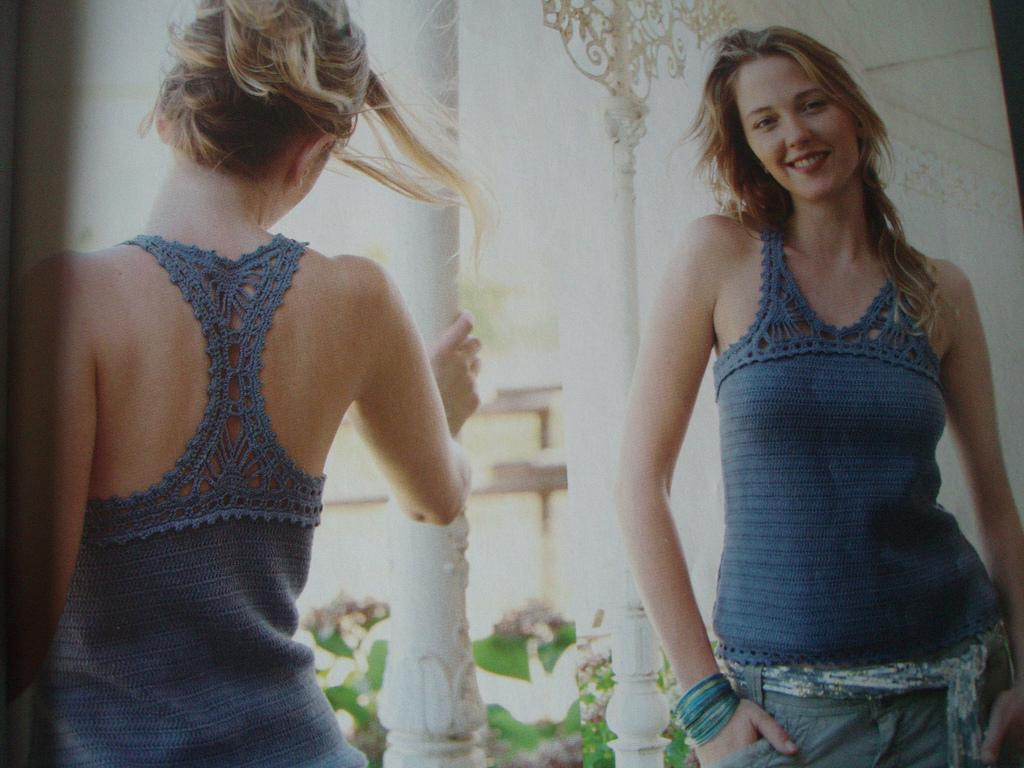What is the main subject in the image? There is a woman standing in the image. Can you describe any other objects or structures in the image? There is a pillar in the image. What is the rate at which the cup is spinning in the image? There is no cup present in the image, so it is not possible to determine a spinning rate. 